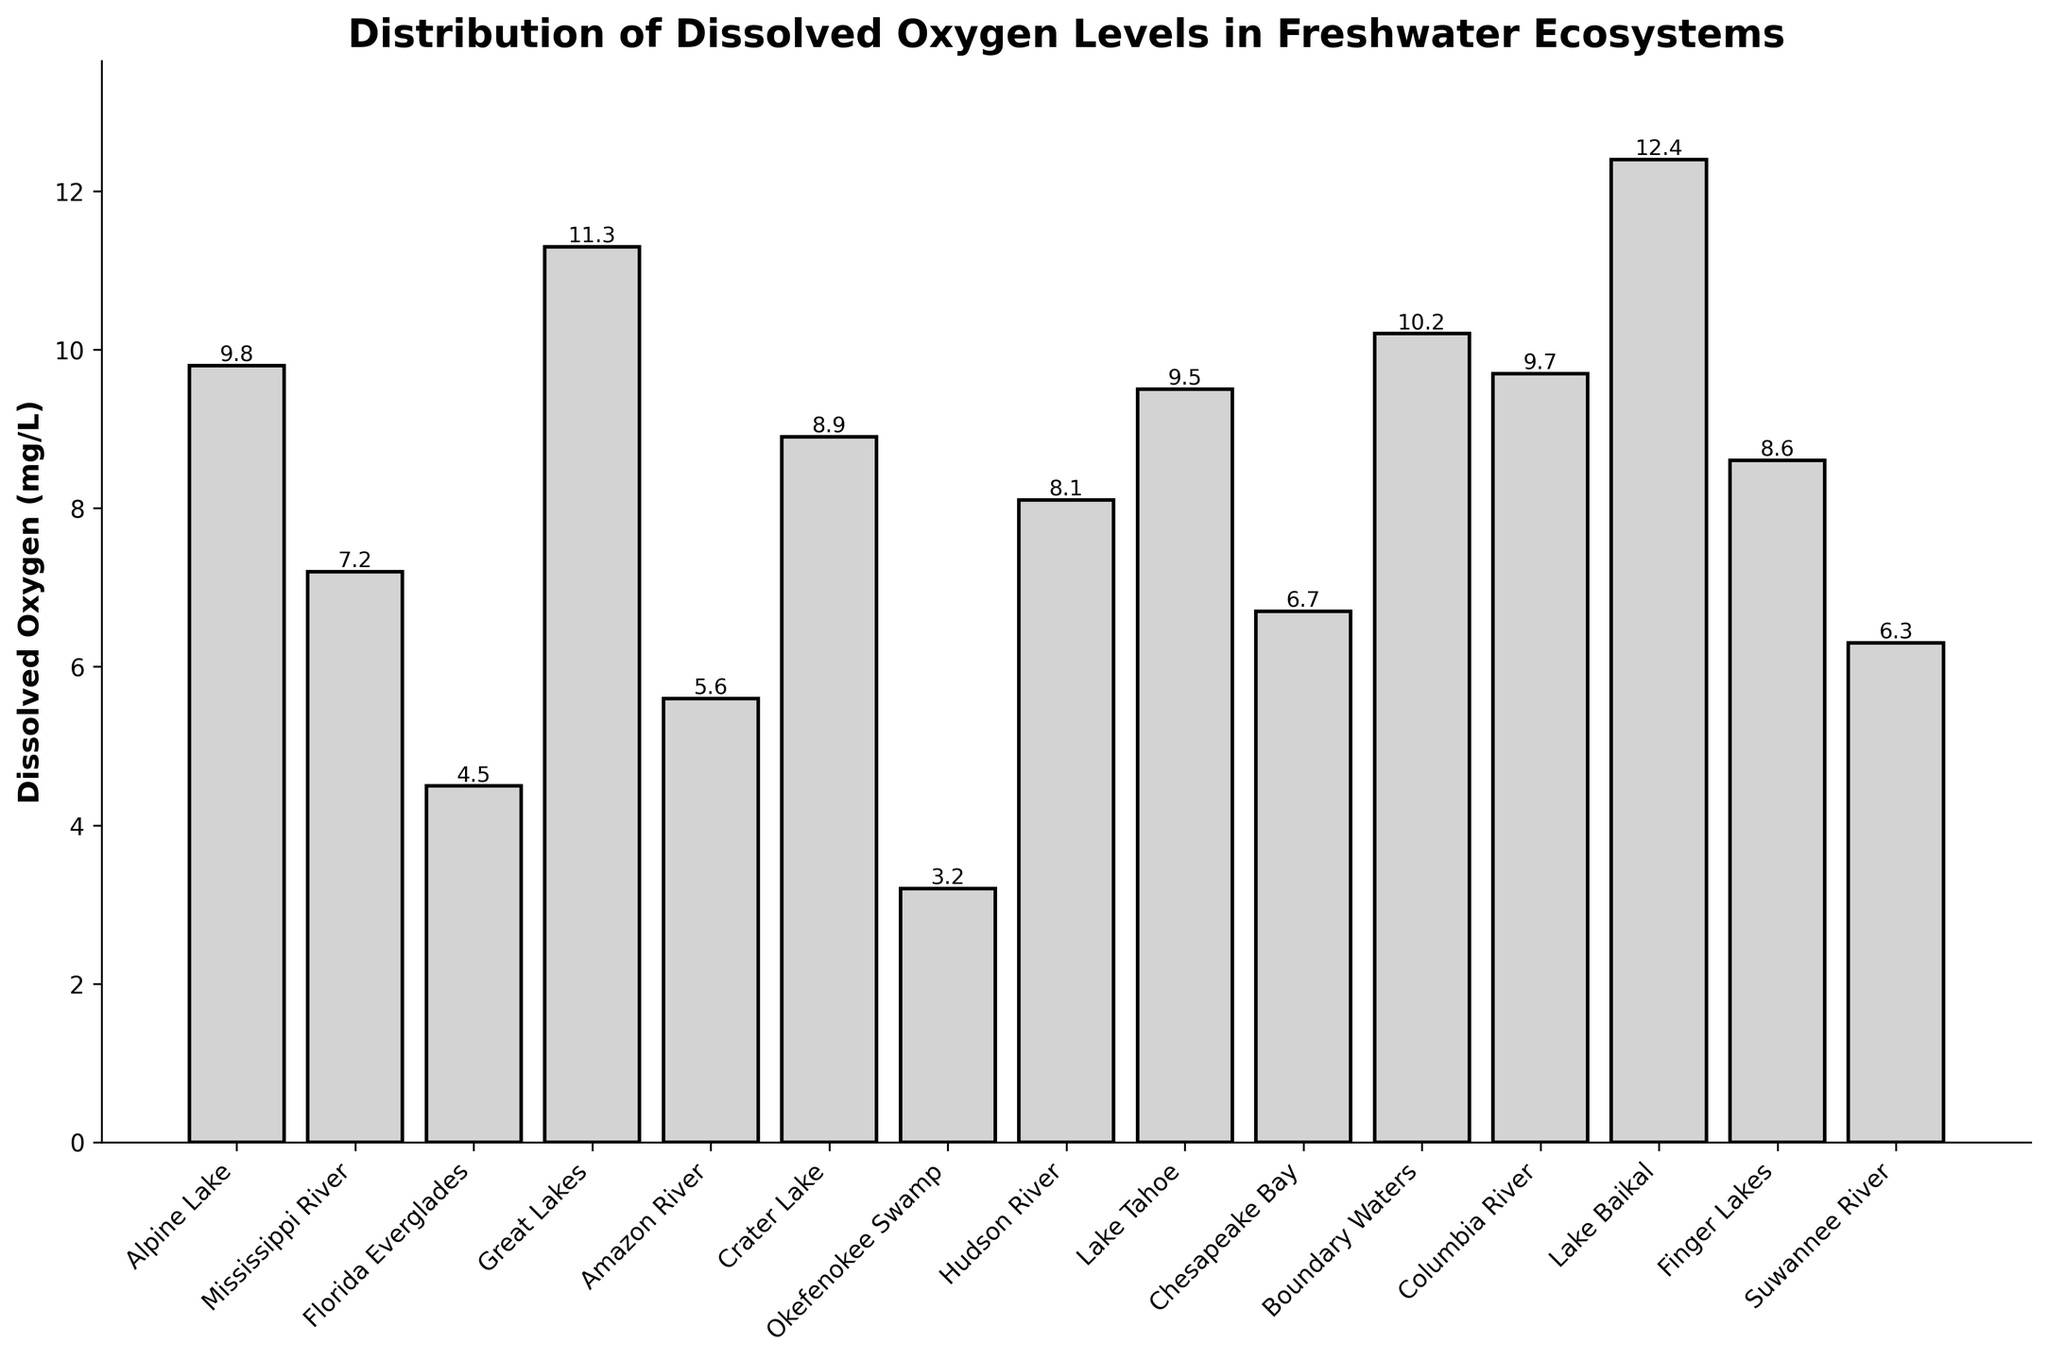Which ecosystem has the highest dissolved oxygen level? First, identify the tallest bar on the bar chart. The corresponding ecosystem will have the highest dissolved oxygen level, which is labeled on top of the bar.
Answer: Lake Baikal Which two ecosystems have the lowest dissolved oxygen levels, and what are those levels? Identify the two shortest bars on the bar chart. The corresponding ecosystems and their labeled dissolved oxygen levels provide the required information.
Answer: Okefenokee Swamp (3.2 mg/L) and Florida Everglades (4.5 mg/L) What is the average dissolved oxygen level of the Great Lakes, Lake Tahoe, and Crater Lake? Add the dissolved oxygen levels of these three ecosystems: 11.3 (Great Lakes) + 9.5 (Lake Tahoe) + 8.9 (Crater Lake) = 29.7. Divide this sum by the number of ecosystems (3) to get the average.
Answer: 9.9 mg/L How much higher is the dissolved oxygen level in Lake Baikal compared to the Okefenokee Swamp? Subtract the dissolved oxygen level of Okefenokee Swamp (3.2 mg/L) from Lake Baikal (12.4 mg/L): 12.4 - 3.2.
Answer: 9.2 mg/L Which rivers have higher dissolved oxygen levels than the Suwannee River, and what are those levels? Compare the dissolved oxygen levels of all rivers with the Suwannee River (6.3 mg/L). The rivers with higher levels are the Mississippi River (7.2 mg/L), Hudson River (8.1 mg/L), and Columbia River (9.7 mg/L).
Answer: Mississippi River (7.2 mg/L), Hudson River (8.1 mg/L), Columbia River (9.7 mg/L) What is the difference in dissolved oxygen levels between the ecosystems with the highest and the lowest levels? Identify the highest (Lake Baikal at 12.4 mg/L) and lowest (Okefenokee Swamp at 3.2 mg/L) dissolved oxygen levels. Subtract the lowest from the highest: 12.4 - 3.2.
Answer: 9.2 mg/L Which ecosystems have a dissolved oxygen level higher than 10 mg/L, and what are those levels? Identify and list the dissolved oxygen levels higher than 10 mg/L: Great Lakes (11.3), Boundary Waters (10.2), and Lake Baikal (12.4).
Answer: Great Lakes (11.3 mg/L), Boundary Waters (10.2 mg/L), Lake Baikal (12.4 mg/L) Is the dissolved oxygen level in the Mississippi River higher or lower than that in Chesapeake Bay? Compare the bar heights and labels: Mississippi River (7.2 mg/L) and Chesapeake Bay (6.7 mg/L).
Answer: Higher Calculate the range of dissolved oxygen levels across all ecosystems. Identify the maximum (Lake Baikal at 12.4 mg/L) and minimum (Okefenokee Swamp at 3.2 mg/L) values. Subtract the minimum from the maximum: 12.4 - 3.2.
Answer: 9.2 mg/L 